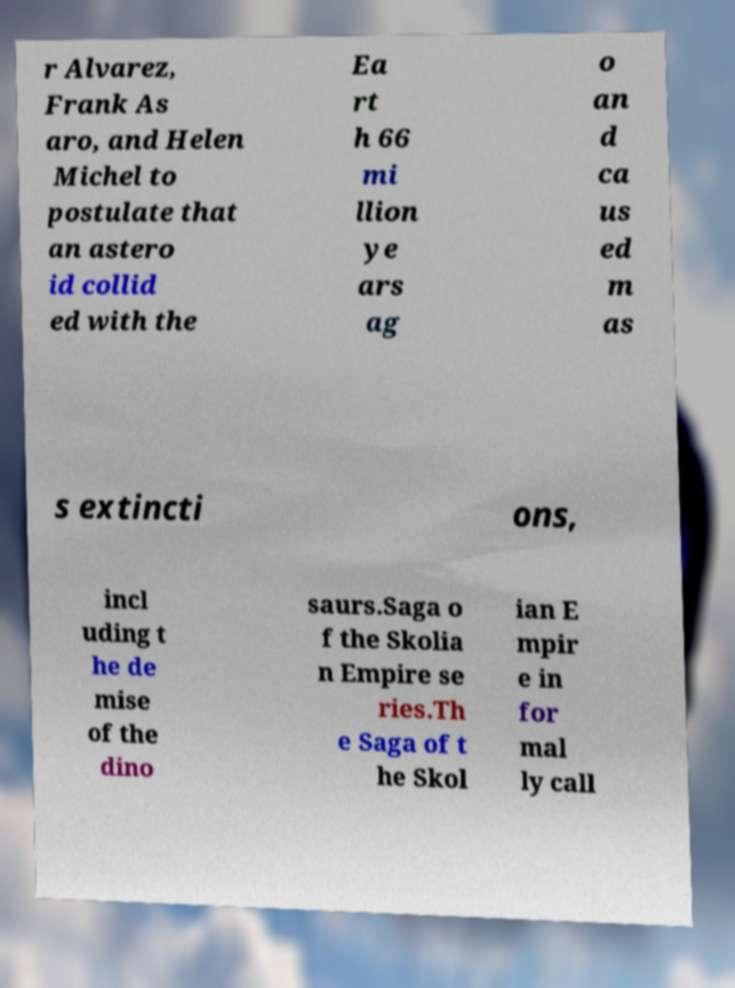What messages or text are displayed in this image? I need them in a readable, typed format. r Alvarez, Frank As aro, and Helen Michel to postulate that an astero id collid ed with the Ea rt h 66 mi llion ye ars ag o an d ca us ed m as s extincti ons, incl uding t he de mise of the dino saurs.Saga o f the Skolia n Empire se ries.Th e Saga of t he Skol ian E mpir e in for mal ly call 